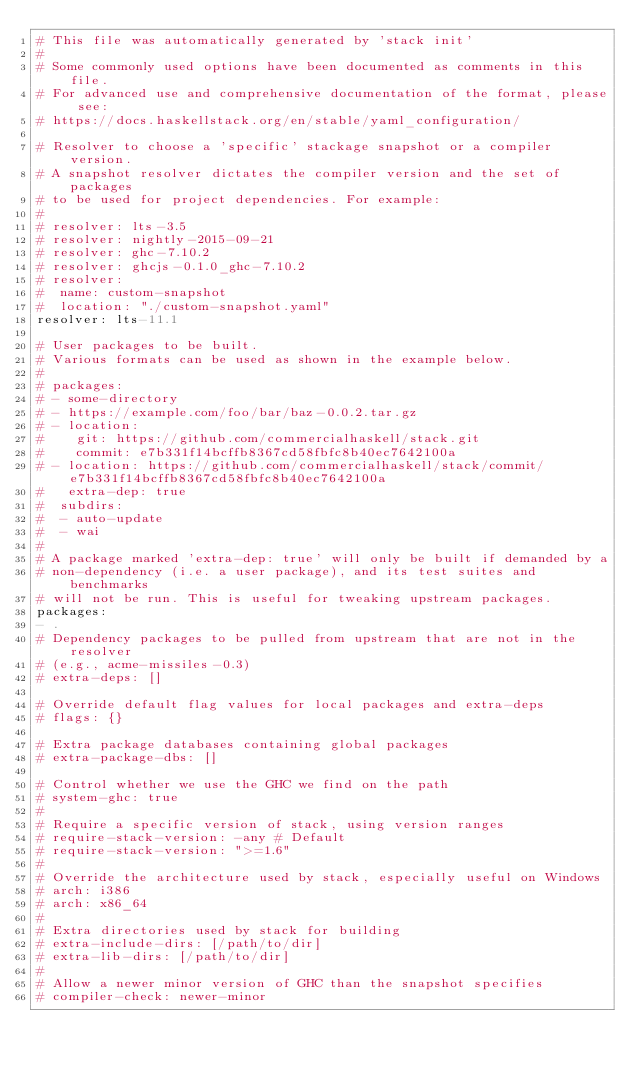<code> <loc_0><loc_0><loc_500><loc_500><_YAML_># This file was automatically generated by 'stack init'
#
# Some commonly used options have been documented as comments in this file.
# For advanced use and comprehensive documentation of the format, please see:
# https://docs.haskellstack.org/en/stable/yaml_configuration/

# Resolver to choose a 'specific' stackage snapshot or a compiler version.
# A snapshot resolver dictates the compiler version and the set of packages
# to be used for project dependencies. For example:
#
# resolver: lts-3.5
# resolver: nightly-2015-09-21
# resolver: ghc-7.10.2
# resolver: ghcjs-0.1.0_ghc-7.10.2
# resolver:
#  name: custom-snapshot
#  location: "./custom-snapshot.yaml"
resolver: lts-11.1

# User packages to be built.
# Various formats can be used as shown in the example below.
#
# packages:
# - some-directory
# - https://example.com/foo/bar/baz-0.0.2.tar.gz
# - location:
#    git: https://github.com/commercialhaskell/stack.git
#    commit: e7b331f14bcffb8367cd58fbfc8b40ec7642100a
# - location: https://github.com/commercialhaskell/stack/commit/e7b331f14bcffb8367cd58fbfc8b40ec7642100a
#   extra-dep: true
#  subdirs:
#  - auto-update
#  - wai
#
# A package marked 'extra-dep: true' will only be built if demanded by a
# non-dependency (i.e. a user package), and its test suites and benchmarks
# will not be run. This is useful for tweaking upstream packages.
packages:
- .
# Dependency packages to be pulled from upstream that are not in the resolver
# (e.g., acme-missiles-0.3)
# extra-deps: []

# Override default flag values for local packages and extra-deps
# flags: {}

# Extra package databases containing global packages
# extra-package-dbs: []

# Control whether we use the GHC we find on the path
# system-ghc: true
#
# Require a specific version of stack, using version ranges
# require-stack-version: -any # Default
# require-stack-version: ">=1.6"
#
# Override the architecture used by stack, especially useful on Windows
# arch: i386
# arch: x86_64
#
# Extra directories used by stack for building
# extra-include-dirs: [/path/to/dir]
# extra-lib-dirs: [/path/to/dir]
#
# Allow a newer minor version of GHC than the snapshot specifies
# compiler-check: newer-minor
</code> 